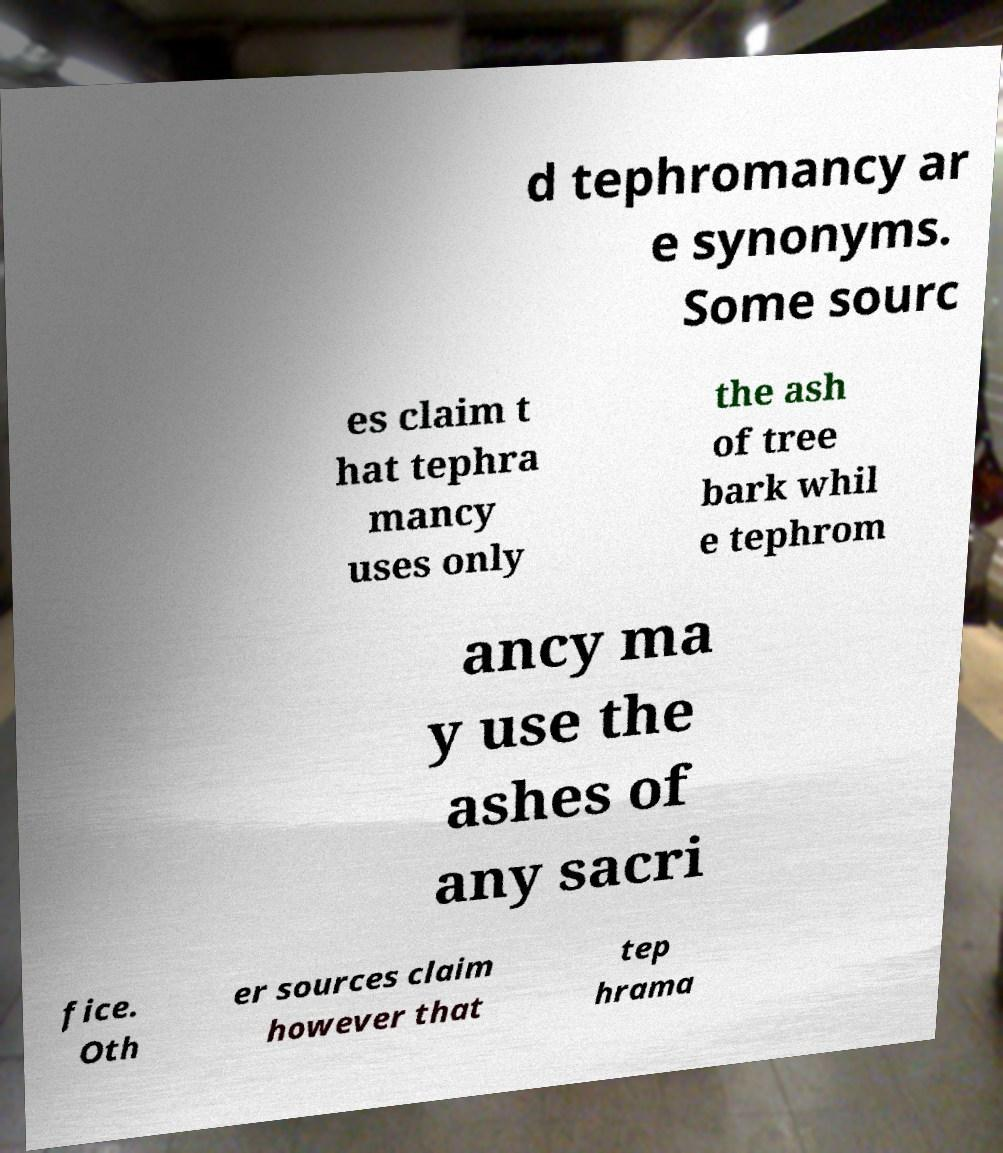For documentation purposes, I need the text within this image transcribed. Could you provide that? d tephromancy ar e synonyms. Some sourc es claim t hat tephra mancy uses only the ash of tree bark whil e tephrom ancy ma y use the ashes of any sacri fice. Oth er sources claim however that tep hrama 